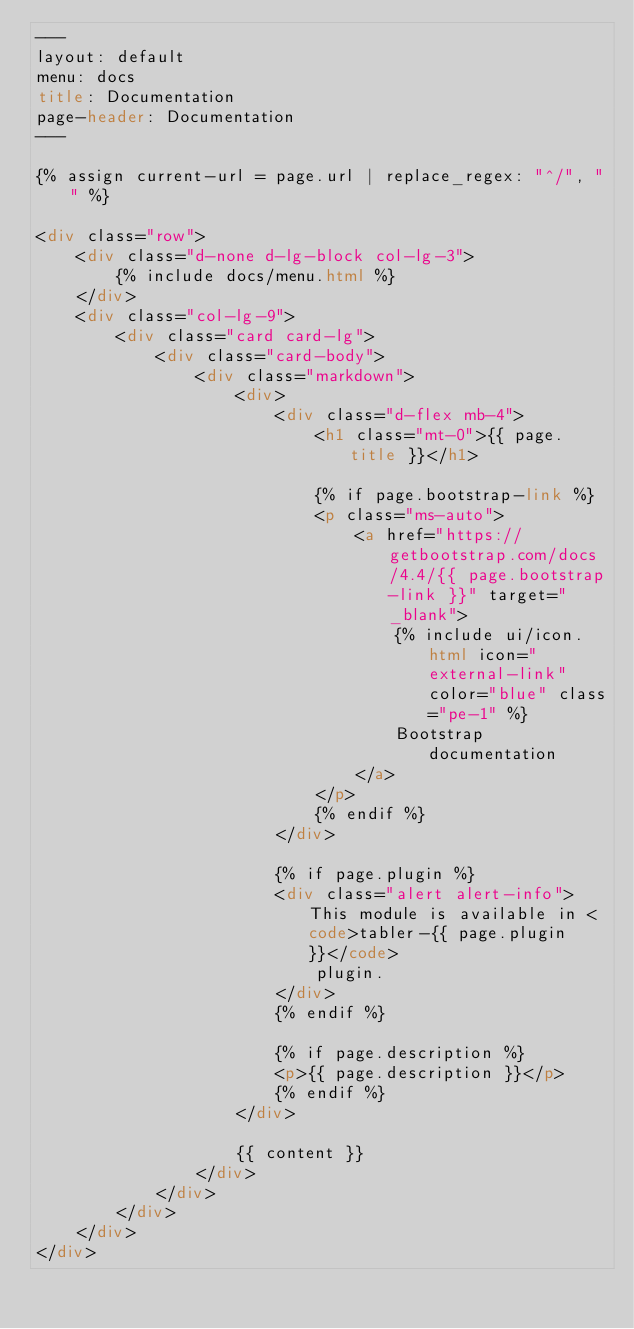<code> <loc_0><loc_0><loc_500><loc_500><_HTML_>---
layout: default
menu: docs
title: Documentation
page-header: Documentation
---

{% assign current-url = page.url | replace_regex: "^/", "" %}

<div class="row">
	<div class="d-none d-lg-block col-lg-3">
		{% include docs/menu.html %}
	</div>
	<div class="col-lg-9">
		<div class="card card-lg">
			<div class="card-body">
				<div class="markdown">
					<div>
						<div class="d-flex mb-4">
							<h1 class="mt-0">{{ page.title }}</h1>

							{% if page.bootstrap-link %}
							<p class="ms-auto">
								<a href="https://getbootstrap.com/docs/4.4/{{ page.bootstrap-link }}" target="_blank">
									{% include ui/icon.html icon="external-link" color="blue" class="pe-1" %}
									Bootstrap documentation
								</a>
							</p>
							{% endif %}
						</div>

						{% if page.plugin %}
						<div class="alert alert-info">This module is available in <code>tabler-{{ page.plugin }}</code>
							plugin.
						</div>
						{% endif %}

						{% if page.description %}
						<p>{{ page.description }}</p>
						{% endif %}
					</div>

					{{ content }}
				</div>
			</div>
		</div>
	</div>
</div>
</code> 